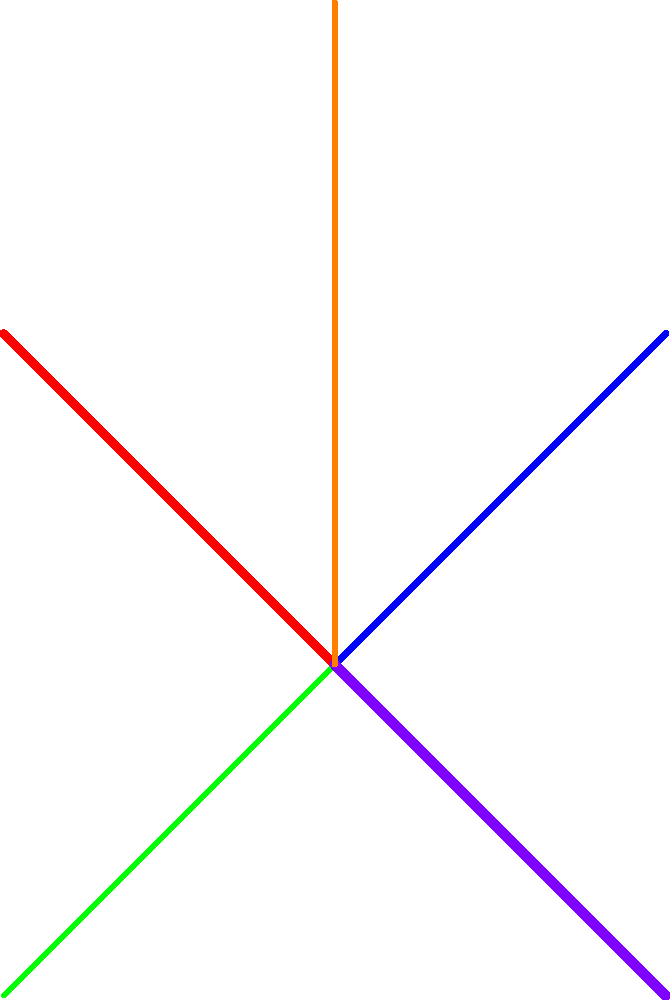Based on the weighted graph representing Turkey's trade relationships, which country appears to have the strongest trade ties with Turkey, and how might this relationship benefit Turkey's global economic position? To answer this question, we need to analyze the graph and interpret the information it provides:

1. The graph shows Turkey at the center, connected to five other countries: Germany, Russia, Egypt, USA, and China.

2. The thickness of the lines represents the volume of trade between Turkey and each country:
   - Turkey-USA: Thickest purple line (Very High)
   - Turkey-Russia: Second thickest red line (High)
   - Turkey-Germany: Medium thick blue line (Medium)
   - Turkey-China: Slightly thinner orange line (Medium-Low)
   - Turkey-Egypt: Thinnest green line (Low)

3. Based on this visual representation, the USA appears to have the strongest trade ties with Turkey, as indicated by the thickest line.

4. The benefits of this strong trade relationship with the USA for Turkey's global economic position include:
   a. Access to a large, developed market for Turkish exports
   b. Potential for technology transfer and innovation
   c. Increased foreign direct investment opportunities
   d. Enhanced geopolitical leverage due to economic ties with a global superpower
   e. Diversification of trade partners, reducing dependence on regional markets

5. This strong relationship with the USA, combined with significant trade ties to other major economies like Russia, Germany, and China, positions Turkey as an important hub in global trade networks.

6. Turkey's diverse trade relationships demonstrate its ability to engage with various economic powers, potentially increasing its influence in international economic forums and negotiations.
Answer: USA; access to large market, technology transfer, investment opportunities, geopolitical leverage, and trade diversification. 